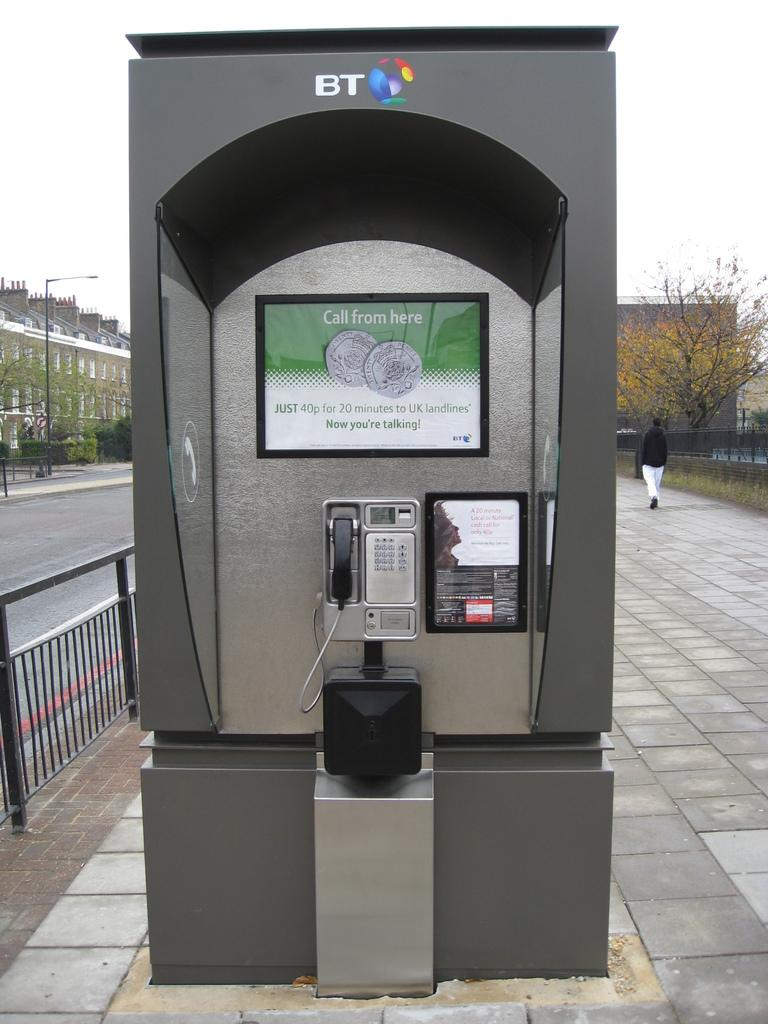<image>
Create a compact narrative representing the image presented. A BT telephone booth in the middle of the walk way. 